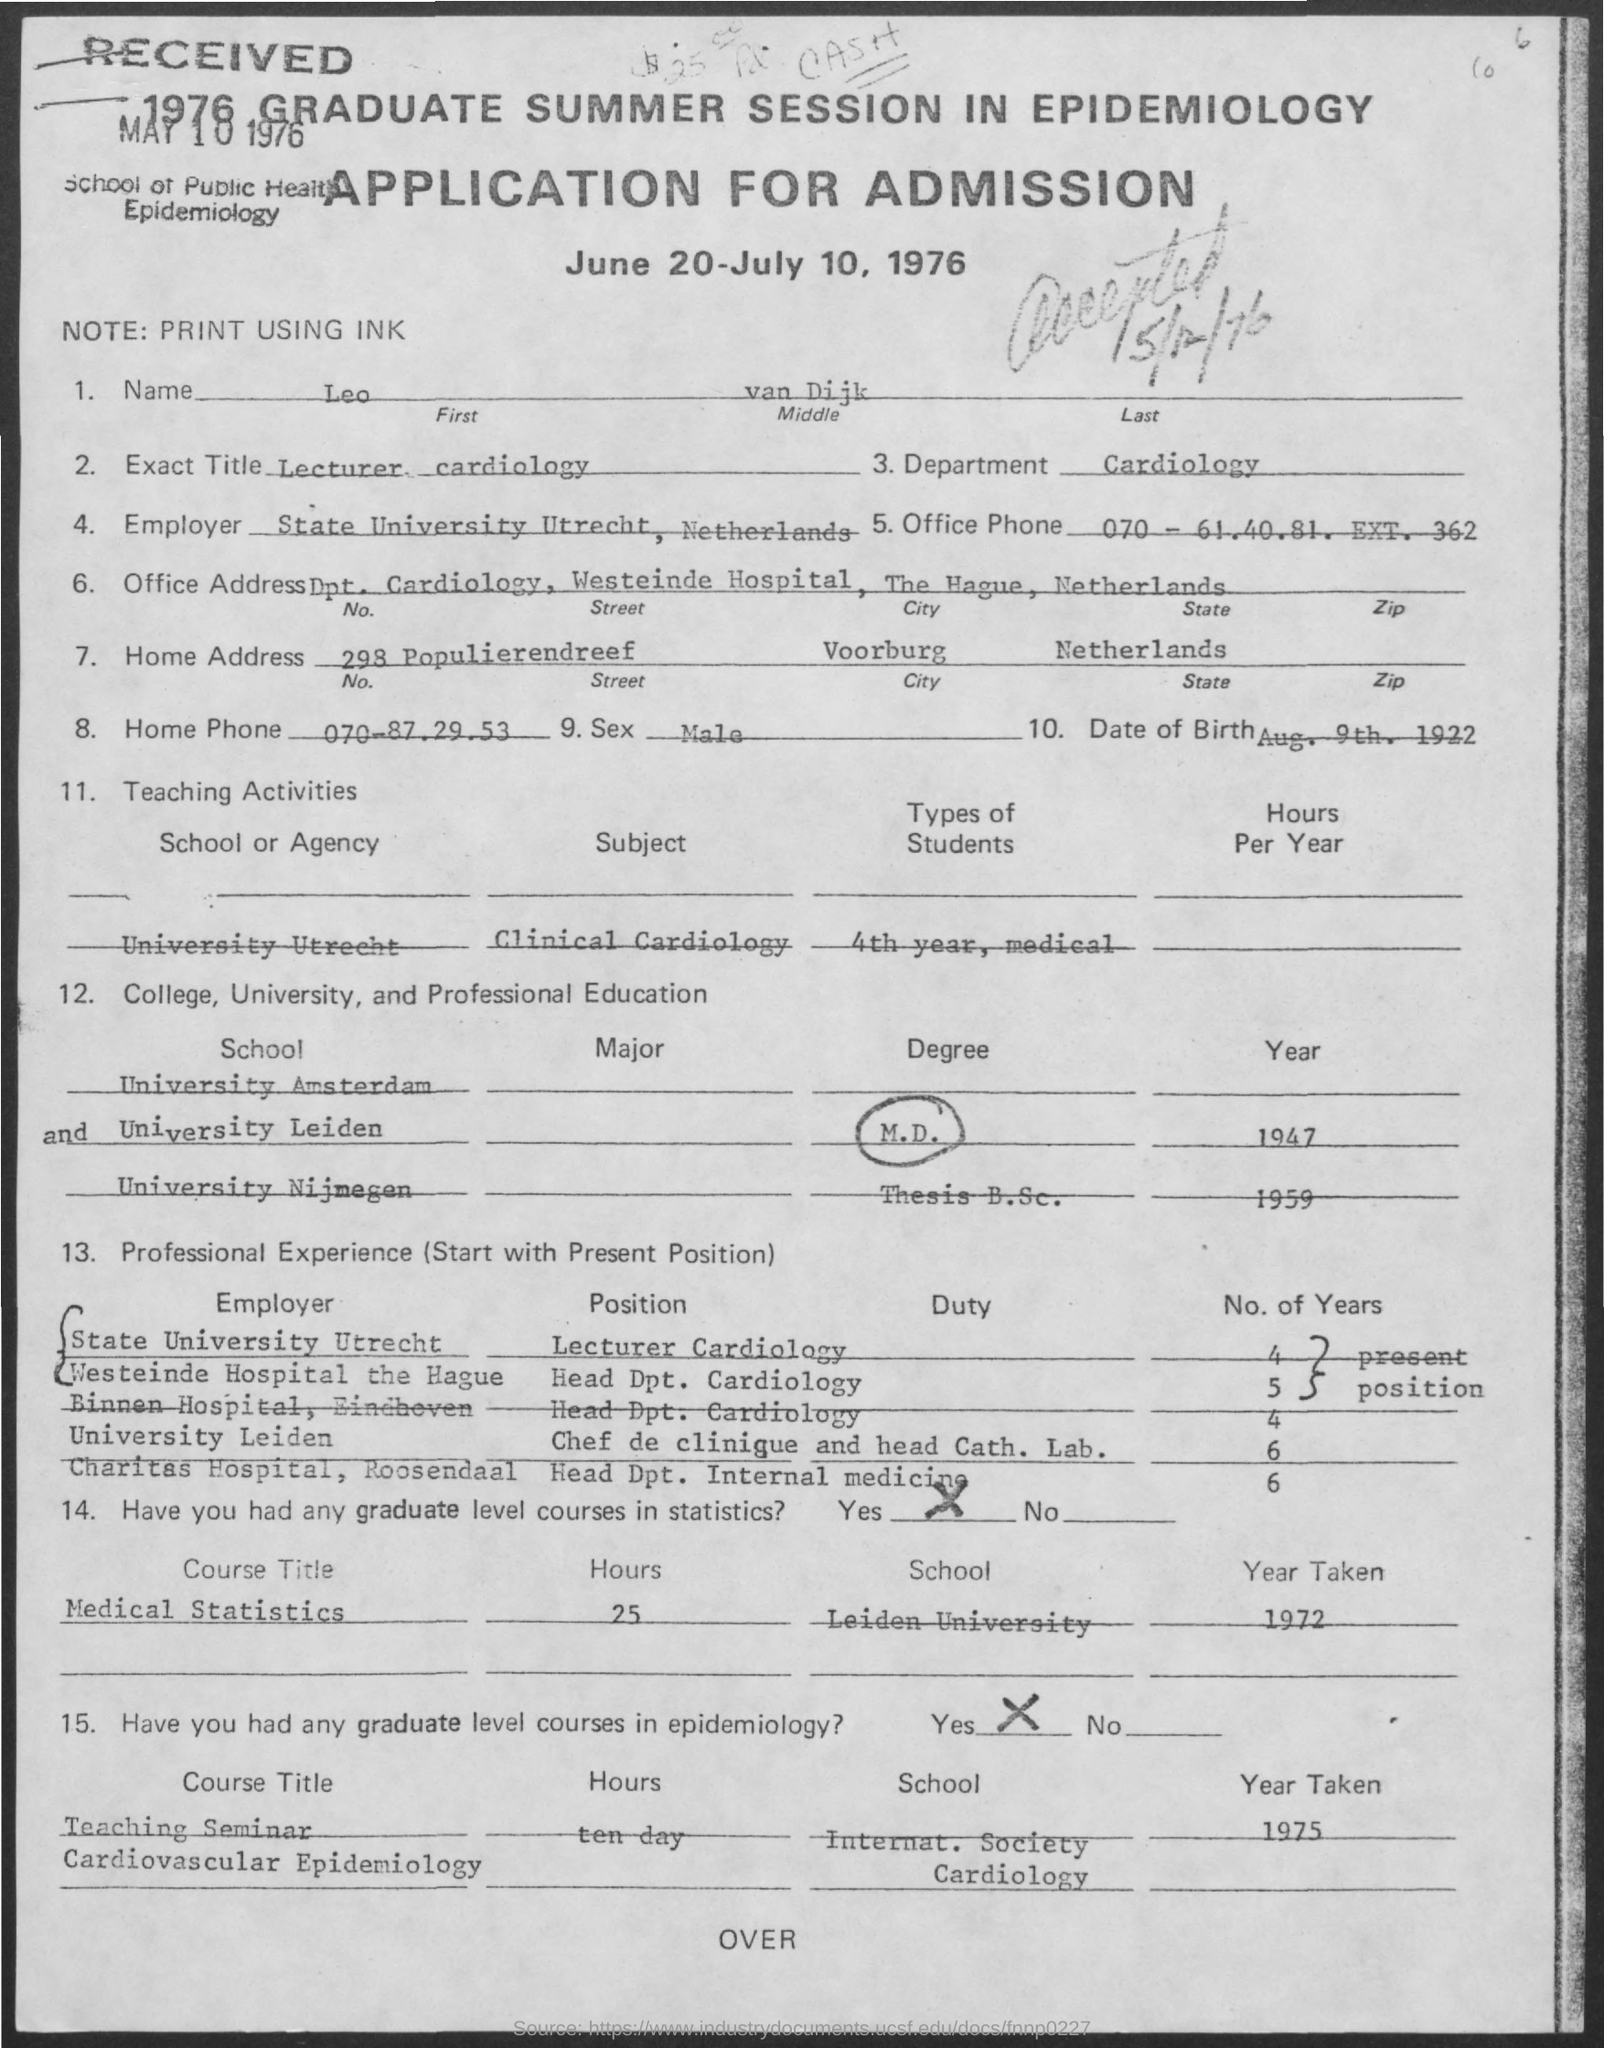What is the first name mentioned in the given application ?
Make the answer very short. Leo. What is the name of the department mentioned in the given application ?
Offer a terse response. Cardiology. What is the home phone number mentioned in the given application ?
Your answer should be compact. 070-87.29.53. What is the sex mentioned in the given application ?
Your answer should be compact. Male. What is the date of birth mentioned in the given application ?
Keep it short and to the point. Aug. 9th. 1922. What is the name of the state mentioned in the home address ?
Provide a short and direct response. Netherlands. 